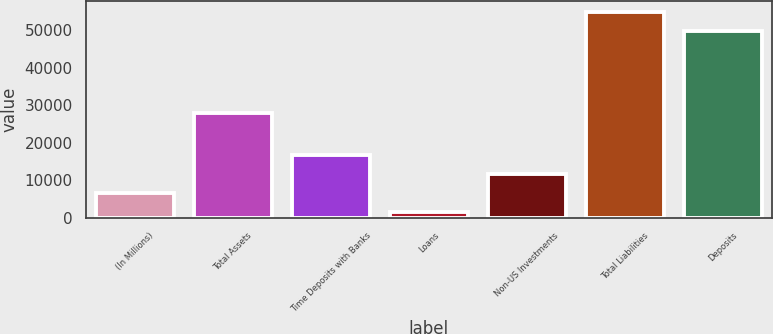<chart> <loc_0><loc_0><loc_500><loc_500><bar_chart><fcel>(In Millions)<fcel>Total Assets<fcel>Time Deposits with Banks<fcel>Loans<fcel>Non-US Investments<fcel>Total Liabilities<fcel>Deposits<nl><fcel>6553.51<fcel>28072.8<fcel>16680.1<fcel>1490.2<fcel>11616.8<fcel>54918<fcel>49854.7<nl></chart> 